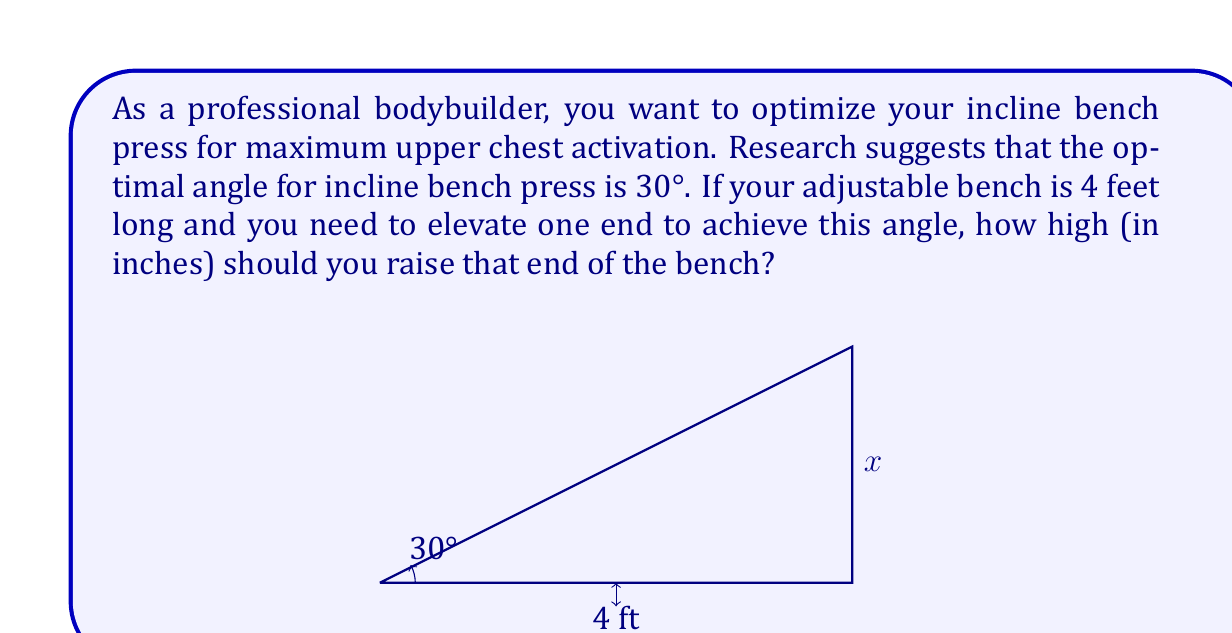Help me with this question. Let's approach this step-by-step using trigonometry:

1) We're dealing with a right triangle, where:
   - The base is the length of the bench (4 feet)
   - The angle we want to achieve is 30°
   - We need to find the height (let's call it x)

2) In this right triangle, we can use the tangent function:

   $\tan(30°) = \frac{\text{opposite}}{\text{adjacent}} = \frac{x}{4}$

3) We know that $\tan(30°) = \frac{1}{\sqrt{3}}$, so we can set up the equation:

   $\frac{1}{\sqrt{3}} = \frac{x}{4}$

4) Cross multiply:

   $4 = x\sqrt{3}$

5) Solve for x:

   $x = \frac{4}{\sqrt{3}} = \frac{4\sqrt{3}}{3}$

6) This gives us the height in feet. To convert to inches, multiply by 12:

   $x(\text{inches}) = \frac{4\sqrt{3}}{3} \times 12 = 16\sqrt{3}$

7) Simplify:

   $x = 16\sqrt{3} \approx 27.71$ inches

Therefore, you should raise the end of the bench approximately 27.71 inches to achieve a 30° incline.
Answer: $27.71$ inches 